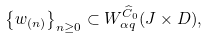Convert formula to latex. <formula><loc_0><loc_0><loc_500><loc_500>\left \{ w _ { ( n ) } \right \} _ { n \geq 0 } \subset { W } _ { \alpha q } ^ { \widehat { C } _ { 0 } } ( J \times D ) ,</formula> 